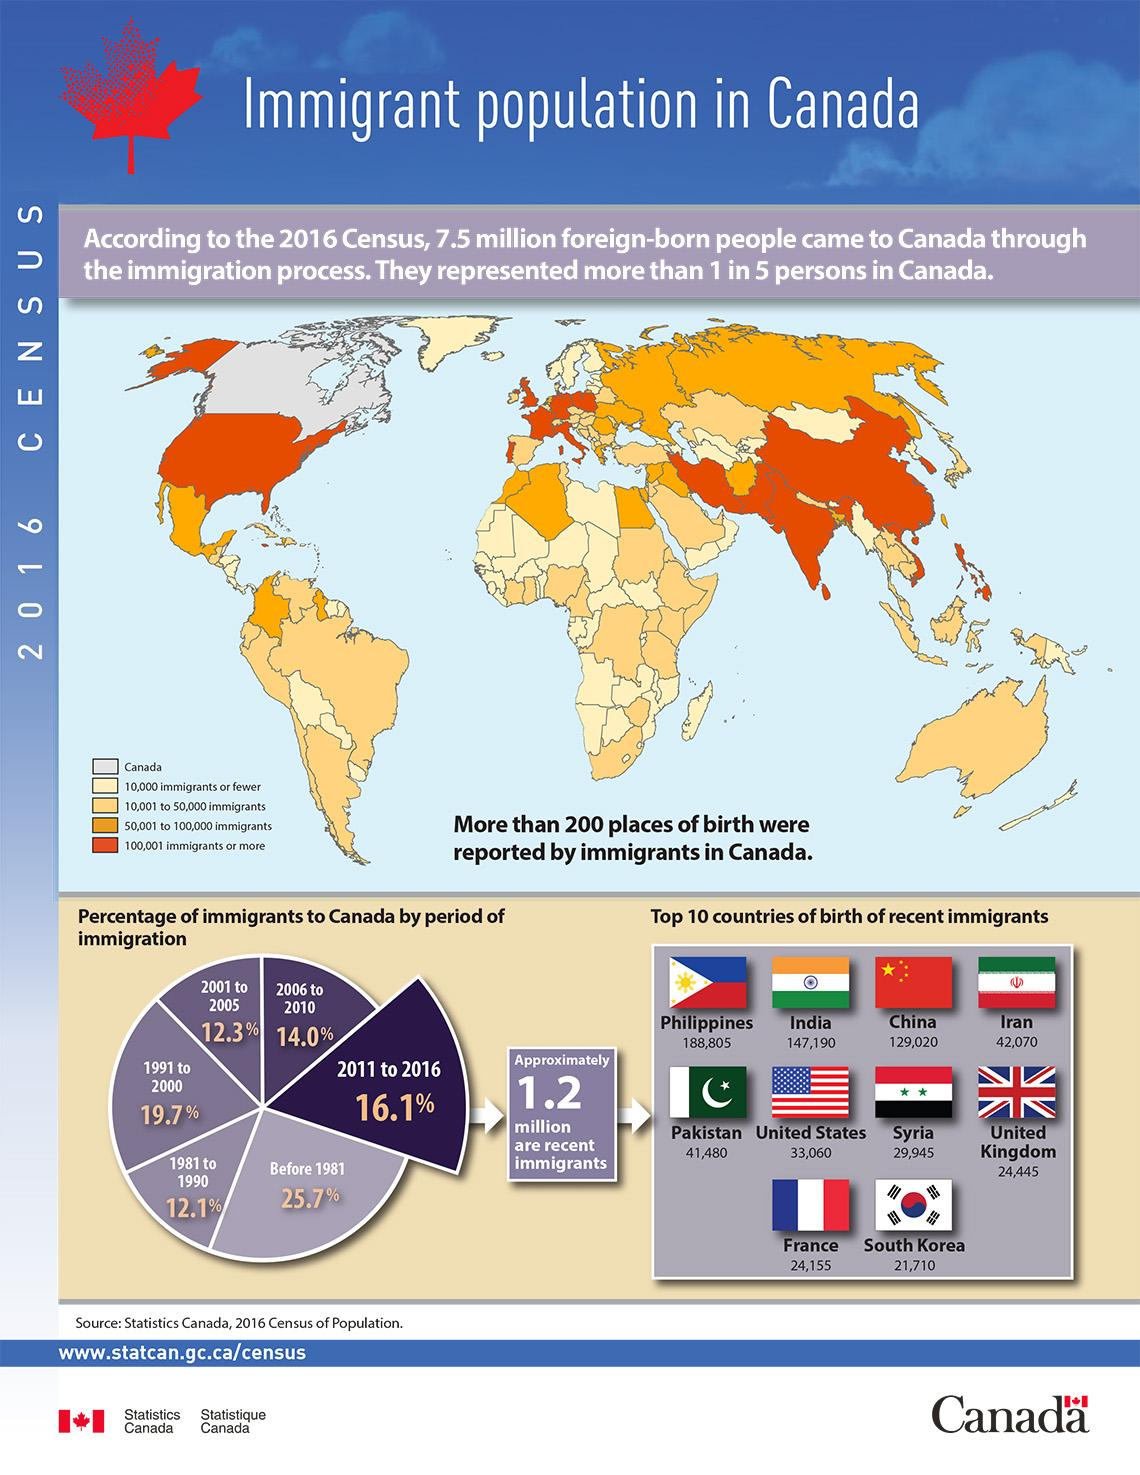Identify some key points in this picture. During the period of 2011-2016, a total of 2,76,210 people from India and China arrived in Canada. Canada had the highest percentage of immigrants before 1981, during which year or period the country welcomed the largest number of immigrants compared to any other year or period in its history. The second-lowest number of immigrants arrived in France during the period of 2011-2016. During the period of 2011-2016, a total of 21,710 individuals from South Korea migrated to Canada. According to the color code, countries with more than 100,001 immigrants to Canada are represented by orange color. 